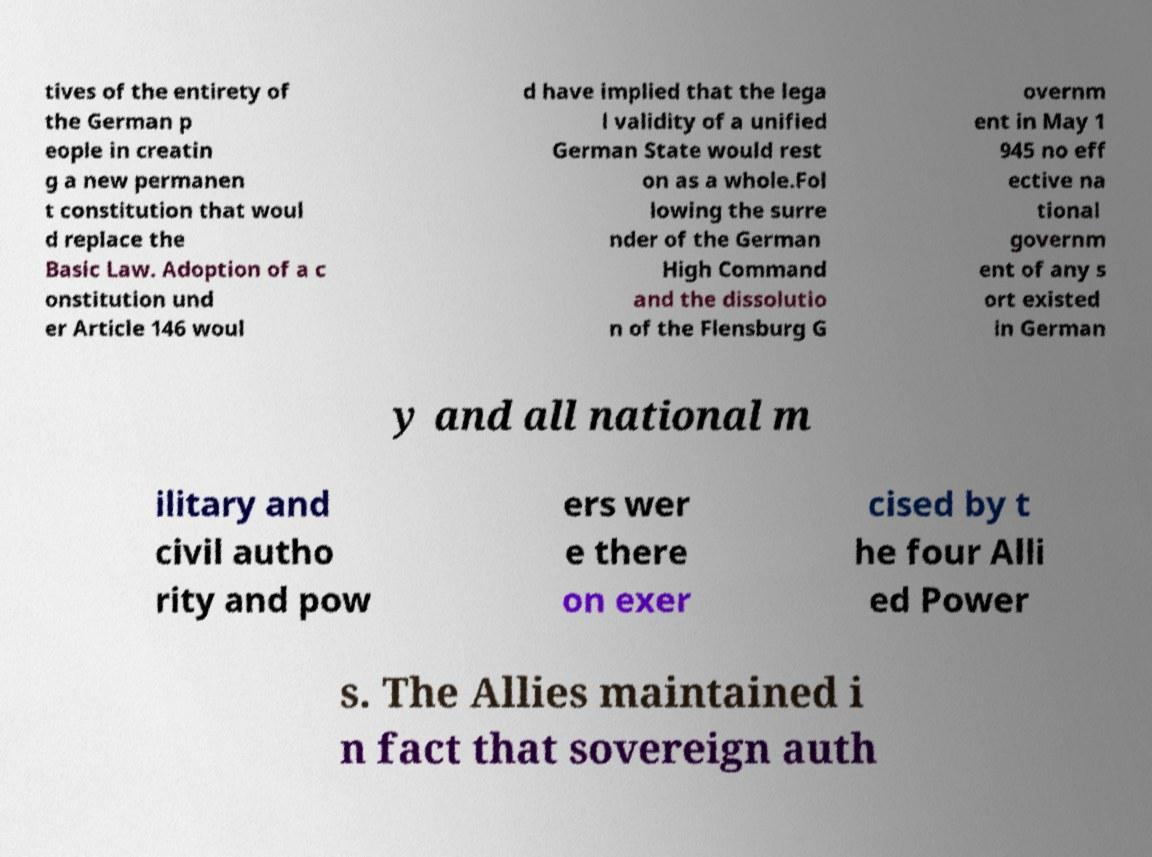There's text embedded in this image that I need extracted. Can you transcribe it verbatim? tives of the entirety of the German p eople in creatin g a new permanen t constitution that woul d replace the Basic Law. Adoption of a c onstitution und er Article 146 woul d have implied that the lega l validity of a unified German State would rest on as a whole.Fol lowing the surre nder of the German High Command and the dissolutio n of the Flensburg G overnm ent in May 1 945 no eff ective na tional governm ent of any s ort existed in German y and all national m ilitary and civil autho rity and pow ers wer e there on exer cised by t he four Alli ed Power s. The Allies maintained i n fact that sovereign auth 